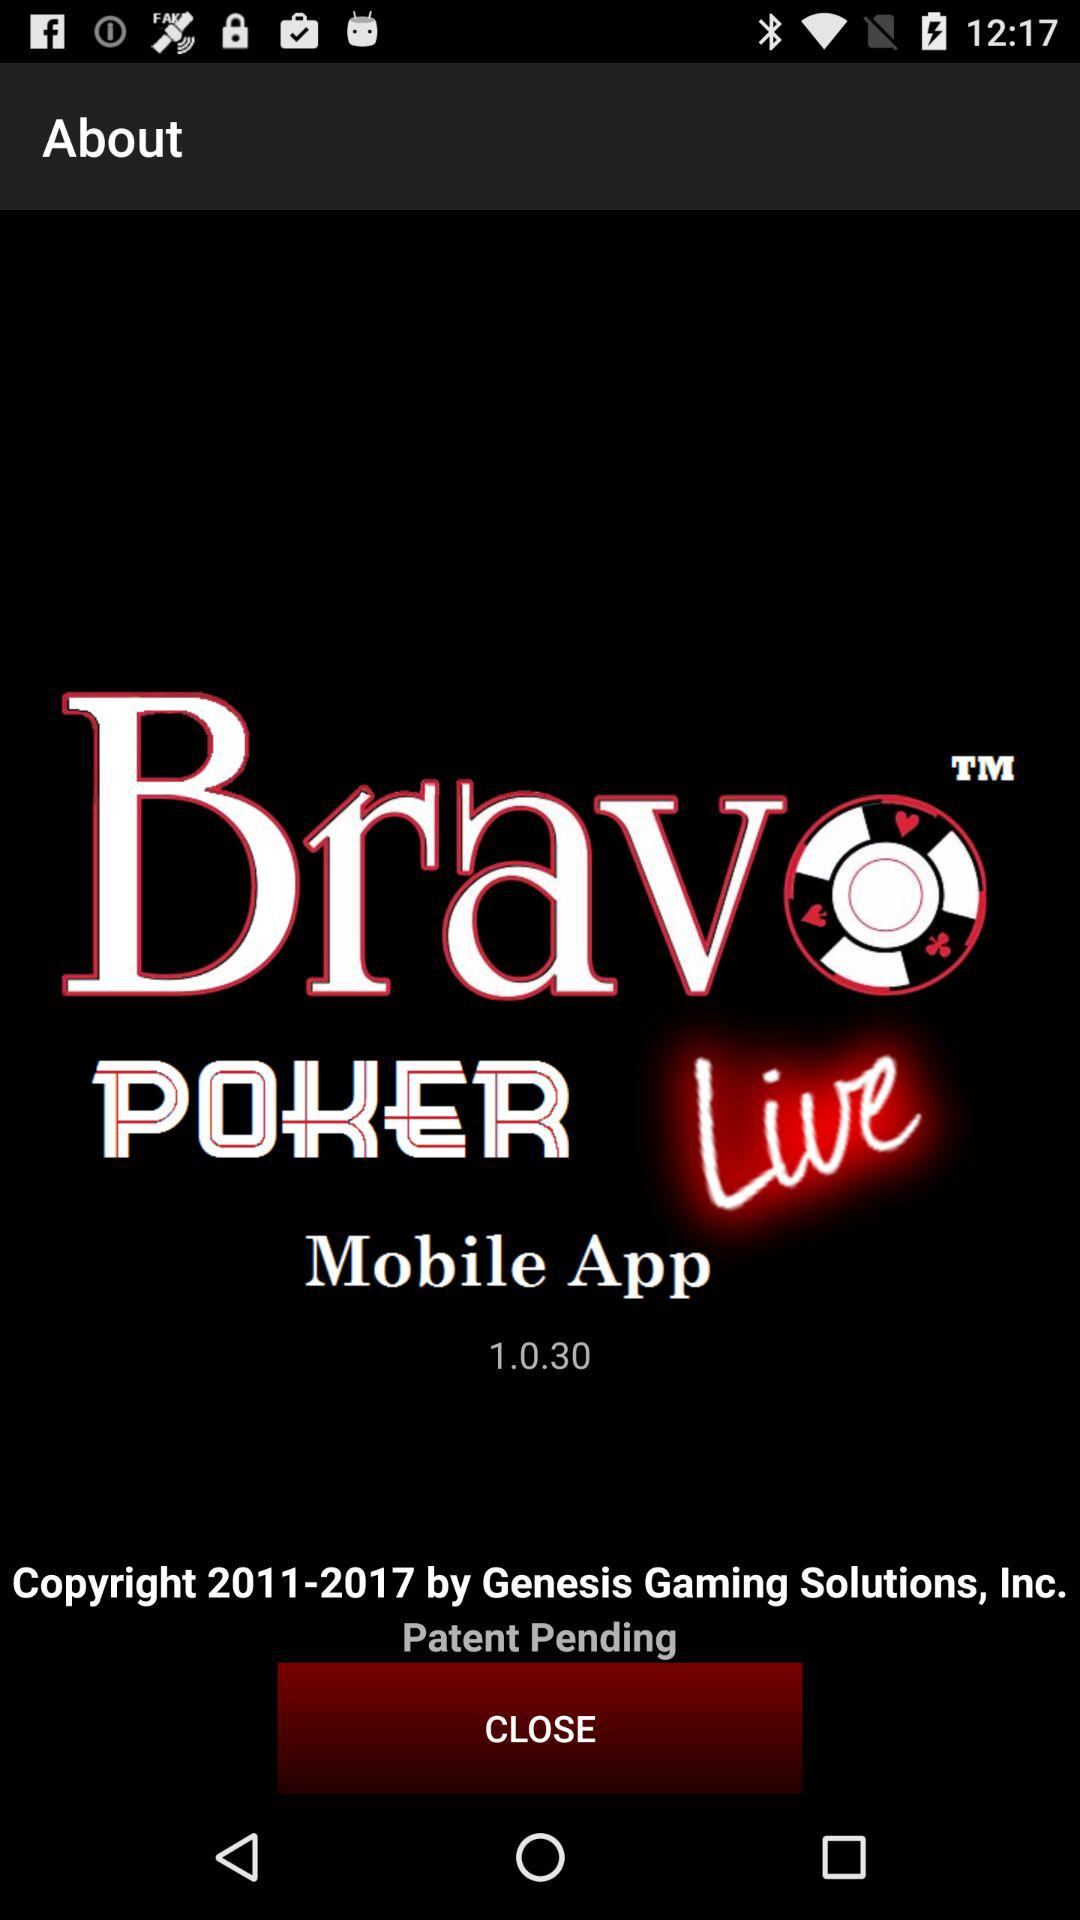What is the version? The version is 1.0.30. 